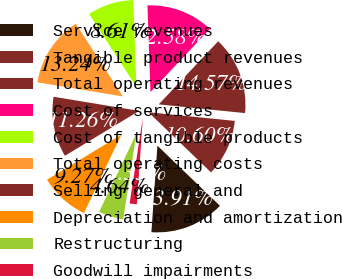<chart> <loc_0><loc_0><loc_500><loc_500><pie_chart><fcel>Service revenues<fcel>Tangible product revenues<fcel>Total operating revenues<fcel>Cost of services<fcel>Cost of tangible products<fcel>Total operating costs<fcel>Selling general and<fcel>Depreciation and amortization<fcel>Restructuring<fcel>Goodwill impairments<nl><fcel>13.91%<fcel>10.6%<fcel>14.57%<fcel>12.58%<fcel>8.61%<fcel>13.24%<fcel>11.26%<fcel>9.27%<fcel>4.64%<fcel>1.33%<nl></chart> 